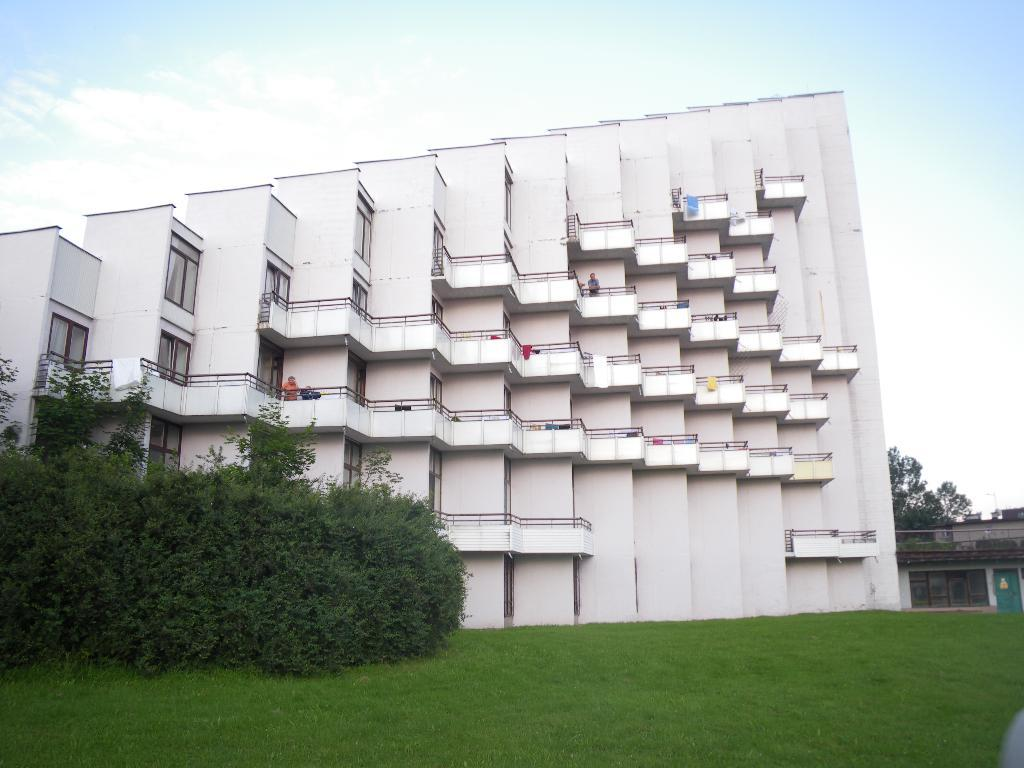What type of vegetation is at the bottom of the image? There is grass at the bottom of the image. What can be seen on the left side of the image? There are trees on the left side of the image. What is present on the right side of the image? There are trees on the right side of the image. What structures are visible in the background of the image? There are buildings in the background of the image. What is visible at the top of the image? The sky is visible at the top of the image. What type of songs can be heard coming from the trees in the image? There is no indication in the image that songs are being played or sung by the trees, so it's not possible to determine what songs might be heard. How many cherries are visible on the buildings in the image? There is no mention of cherries in the image, so it's not possible to determine how many cherries might be on the buildings. 